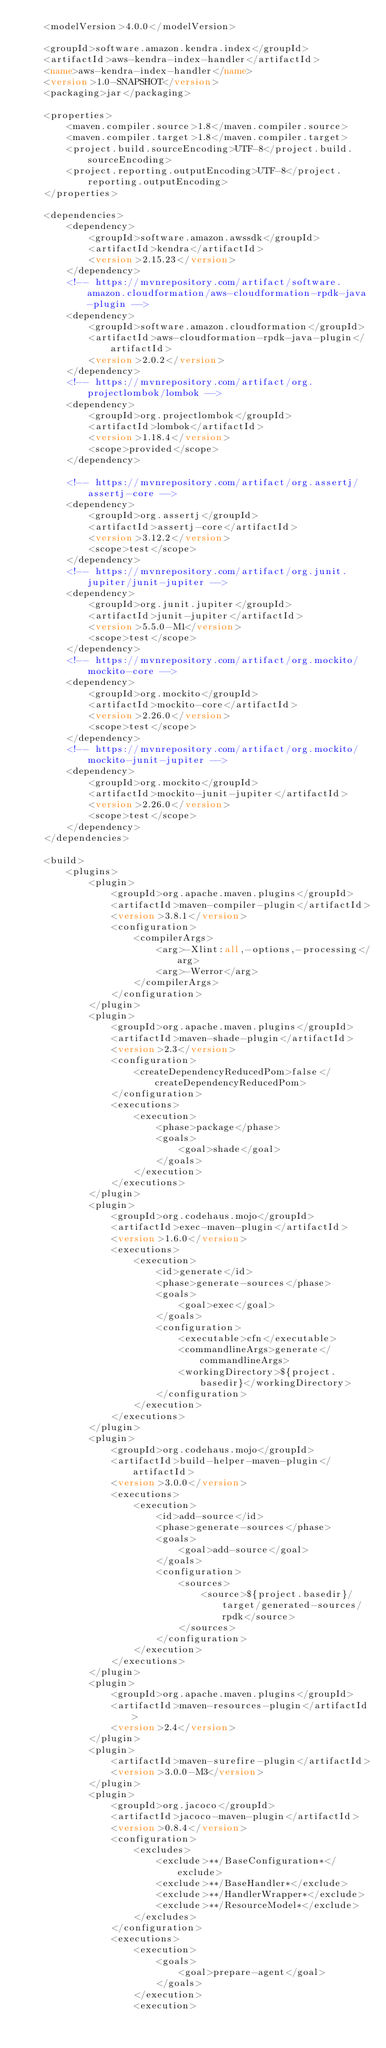Convert code to text. <code><loc_0><loc_0><loc_500><loc_500><_XML_>    <modelVersion>4.0.0</modelVersion>

    <groupId>software.amazon.kendra.index</groupId>
    <artifactId>aws-kendra-index-handler</artifactId>
    <name>aws-kendra-index-handler</name>
    <version>1.0-SNAPSHOT</version>
    <packaging>jar</packaging>

    <properties>
        <maven.compiler.source>1.8</maven.compiler.source>
        <maven.compiler.target>1.8</maven.compiler.target>
        <project.build.sourceEncoding>UTF-8</project.build.sourceEncoding>
        <project.reporting.outputEncoding>UTF-8</project.reporting.outputEncoding>
    </properties>

    <dependencies>
        <dependency>
            <groupId>software.amazon.awssdk</groupId>
            <artifactId>kendra</artifactId>
            <version>2.15.23</version>
        </dependency>
        <!-- https://mvnrepository.com/artifact/software.amazon.cloudformation/aws-cloudformation-rpdk-java-plugin -->
        <dependency>
            <groupId>software.amazon.cloudformation</groupId>
            <artifactId>aws-cloudformation-rpdk-java-plugin</artifactId>
            <version>2.0.2</version>
        </dependency>
        <!-- https://mvnrepository.com/artifact/org.projectlombok/lombok -->
        <dependency>
            <groupId>org.projectlombok</groupId>
            <artifactId>lombok</artifactId>
            <version>1.18.4</version>
            <scope>provided</scope>
        </dependency>

        <!-- https://mvnrepository.com/artifact/org.assertj/assertj-core -->
        <dependency>
            <groupId>org.assertj</groupId>
            <artifactId>assertj-core</artifactId>
            <version>3.12.2</version>
            <scope>test</scope>
        </dependency>
        <!-- https://mvnrepository.com/artifact/org.junit.jupiter/junit-jupiter -->
        <dependency>
            <groupId>org.junit.jupiter</groupId>
            <artifactId>junit-jupiter</artifactId>
            <version>5.5.0-M1</version>
            <scope>test</scope>
        </dependency>
        <!-- https://mvnrepository.com/artifact/org.mockito/mockito-core -->
        <dependency>
            <groupId>org.mockito</groupId>
            <artifactId>mockito-core</artifactId>
            <version>2.26.0</version>
            <scope>test</scope>
        </dependency>
        <!-- https://mvnrepository.com/artifact/org.mockito/mockito-junit-jupiter -->
        <dependency>
            <groupId>org.mockito</groupId>
            <artifactId>mockito-junit-jupiter</artifactId>
            <version>2.26.0</version>
            <scope>test</scope>
        </dependency>
    </dependencies>

    <build>
        <plugins>
            <plugin>
                <groupId>org.apache.maven.plugins</groupId>
                <artifactId>maven-compiler-plugin</artifactId>
                <version>3.8.1</version>
                <configuration>
                    <compilerArgs>
                        <arg>-Xlint:all,-options,-processing</arg>
                        <arg>-Werror</arg>
                    </compilerArgs>
                </configuration>
            </plugin>
            <plugin>
                <groupId>org.apache.maven.plugins</groupId>
                <artifactId>maven-shade-plugin</artifactId>
                <version>2.3</version>
                <configuration>
                    <createDependencyReducedPom>false</createDependencyReducedPom>
                </configuration>
                <executions>
                    <execution>
                        <phase>package</phase>
                        <goals>
                            <goal>shade</goal>
                        </goals>
                    </execution>
                </executions>
            </plugin>
            <plugin>
                <groupId>org.codehaus.mojo</groupId>
                <artifactId>exec-maven-plugin</artifactId>
                <version>1.6.0</version>
                <executions>
                    <execution>
                        <id>generate</id>
                        <phase>generate-sources</phase>
                        <goals>
                            <goal>exec</goal>
                        </goals>
                        <configuration>
                            <executable>cfn</executable>
                            <commandlineArgs>generate</commandlineArgs>
                            <workingDirectory>${project.basedir}</workingDirectory>
                        </configuration>
                    </execution>
                </executions>
            </plugin>
            <plugin>
                <groupId>org.codehaus.mojo</groupId>
                <artifactId>build-helper-maven-plugin</artifactId>
                <version>3.0.0</version>
                <executions>
                    <execution>
                        <id>add-source</id>
                        <phase>generate-sources</phase>
                        <goals>
                            <goal>add-source</goal>
                        </goals>
                        <configuration>
                            <sources>
                                <source>${project.basedir}/target/generated-sources/rpdk</source>
                            </sources>
                        </configuration>
                    </execution>
                </executions>
            </plugin>
            <plugin>
                <groupId>org.apache.maven.plugins</groupId>
                <artifactId>maven-resources-plugin</artifactId>
                <version>2.4</version>
            </plugin>
            <plugin>
                <artifactId>maven-surefire-plugin</artifactId>
                <version>3.0.0-M3</version>
            </plugin>
            <plugin>
                <groupId>org.jacoco</groupId>
                <artifactId>jacoco-maven-plugin</artifactId>
                <version>0.8.4</version>
                <configuration>
                    <excludes>
                        <exclude>**/BaseConfiguration*</exclude>
                        <exclude>**/BaseHandler*</exclude>
                        <exclude>**/HandlerWrapper*</exclude>
                        <exclude>**/ResourceModel*</exclude>
                    </excludes>
                </configuration>
                <executions>
                    <execution>
                        <goals>
                            <goal>prepare-agent</goal>
                        </goals>
                    </execution>
                    <execution></code> 